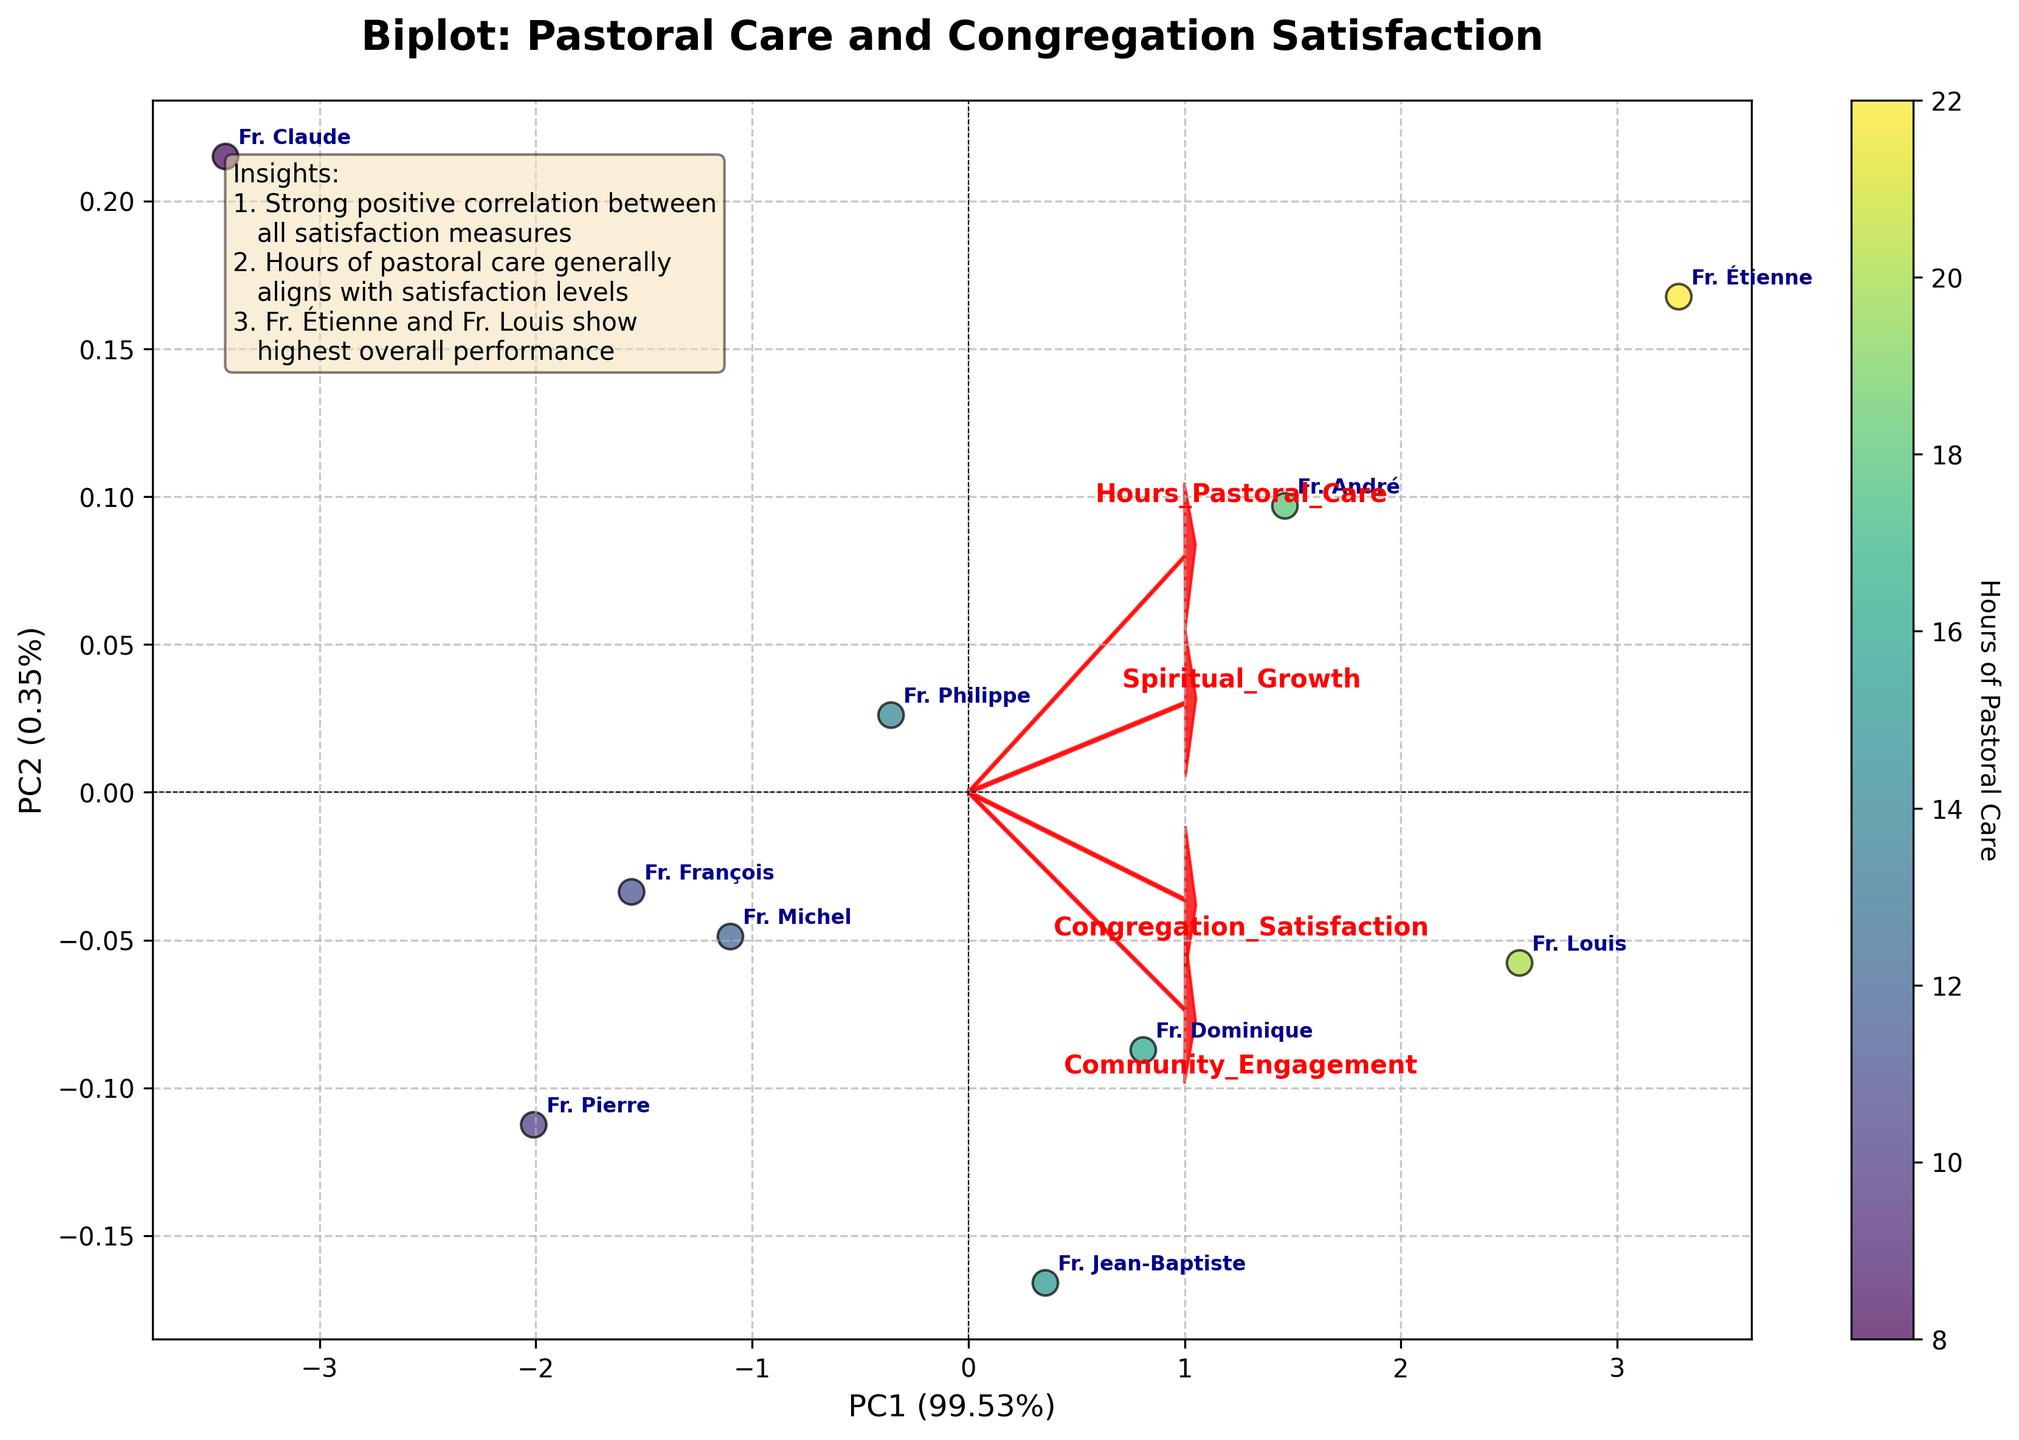What's the title of the figure? The title of the figure is located at the top center and reads "Biplot: Pastoral Care and Congregation Satisfaction".
Answer: Biplot: Pastoral Care and Congregation Satisfaction How many priests are represented in the biplot? Each data point in the biplot represents a priest, and their names are annotated next to the points. By counting these names, we see there are 10 priests in total.
Answer: 10 Which priest has the highest number of hours in pastoral care? The color gradient represents the number of hours spent on pastoral care, with darker colors indicating higher hours. Fr. Étienne's point is the darkest, showing he has the highest hours.
Answer: Fr. Étienne How are 'Community Engagement' and 'Spiritual Growth' related according to the loadings? Observing the red arrows for 'Community Engagement' and 'Spiritual Growth', they point in approximately the same direction, indicating a strong positive correlation.
Answer: Strong positive correlation Which two priests have the closest scores in the biplot? By looking at the proximity of data points representing the priests, Fr. Jean-Baptiste and Fr. Dominique are closest to each other, indicating they have similar scores.
Answer: Fr. Jean-Baptiste and Fr. Dominique How much variation is explained by the first principal component (PC1)? The percentage of variation explained by PC1 is displayed on the x-axis label, and it reads "PC1 (56%)", meaning 56% of the variation in the data is explained by PC1.
Answer: 56% What is the direction of the 'Congregation Satisfaction' loading vector? The direction of the 'Congregation Satisfaction' loading vector points positively along both PC1 and PC2 axes, indicating it increases with both principal components.
Answer: Positive along PC1 and PC2 Which feature has the strongest influence on PC1? The feature with the longest loading vector on the PC1 axis has the strongest influence. 'Community Engagement' has the longest arrow on PC1, thus having a strong influence on PC1.
Answer: Community Engagement Compare Fr. Claude and Fr. Louis in terms of principal component scores. Who is more aligned with PC1? Fr. Louis is positioned further along the PC1 axis compared to Fr. Claude, indicating Fr. Louis is more aligned with PC1.
Answer: Fr. Louis What insights are provided in the figure's text box? The text box in the figure summarizes three insights: a strong positive correlation between all satisfaction measures, pastoral care hours generally aligning with satisfaction levels, and Fr. Étienne and Fr. Louis demonstrating the highest overall performance.
Answer: Three insights: strong correlation among satisfaction measures, alignment of pastoral care hours with satisfaction, Fr. Étienne and Fr. Louis's high performance 